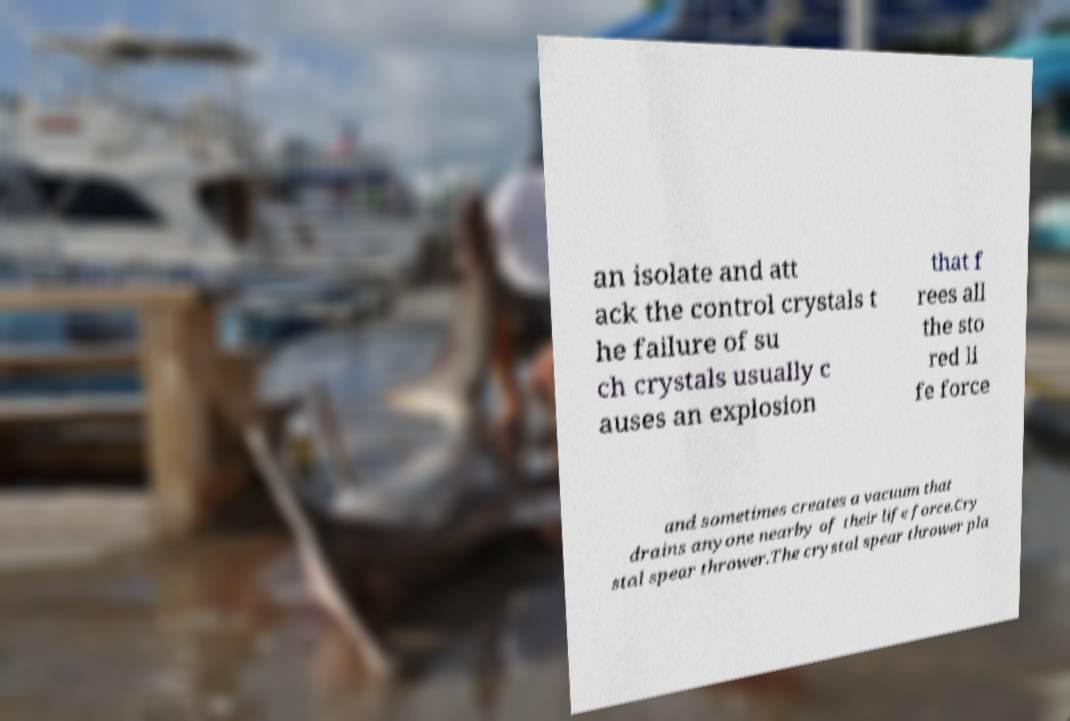Can you read and provide the text displayed in the image?This photo seems to have some interesting text. Can you extract and type it out for me? an isolate and att ack the control crystals t he failure of su ch crystals usually c auses an explosion that f rees all the sto red li fe force and sometimes creates a vacuum that drains anyone nearby of their life force.Cry stal spear thrower.The crystal spear thrower pla 